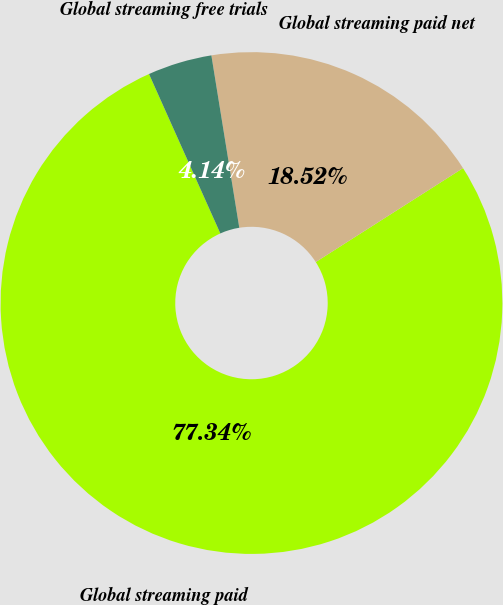Convert chart to OTSL. <chart><loc_0><loc_0><loc_500><loc_500><pie_chart><fcel>Global streaming paid<fcel>Global streaming paid net<fcel>Global streaming free trials<nl><fcel>77.34%<fcel>18.52%<fcel>4.14%<nl></chart> 